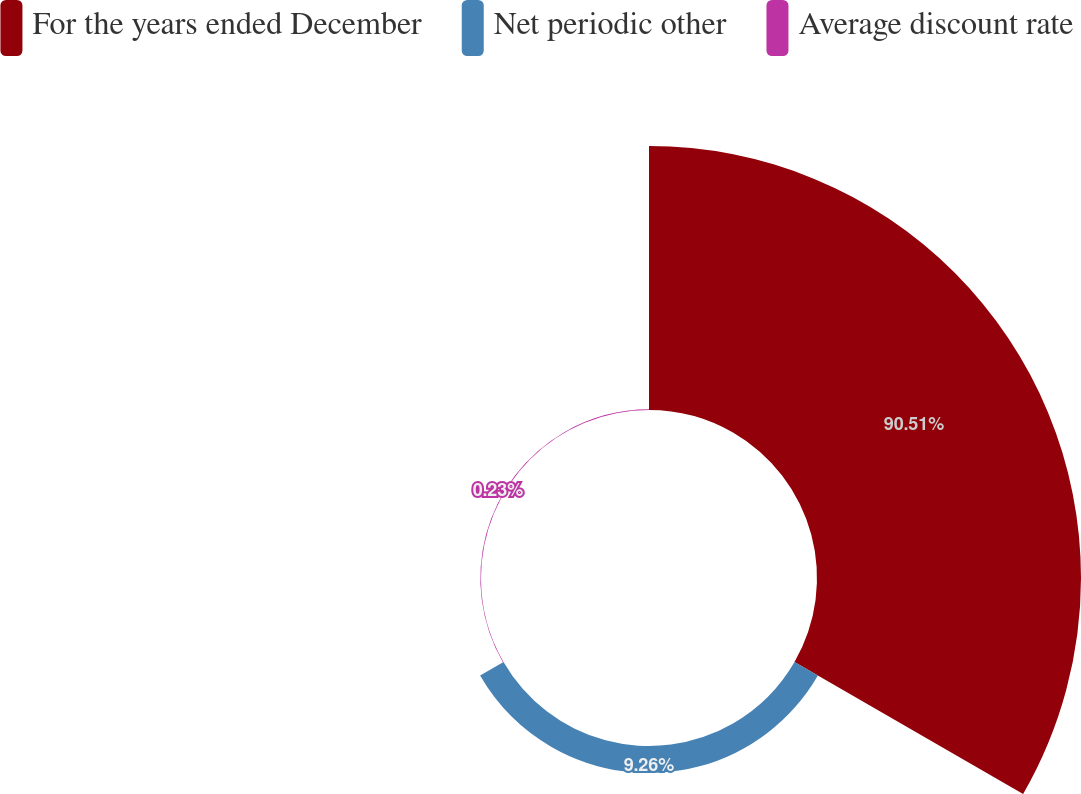<chart> <loc_0><loc_0><loc_500><loc_500><pie_chart><fcel>For the years ended December<fcel>Net periodic other<fcel>Average discount rate<nl><fcel>90.5%<fcel>9.26%<fcel>0.23%<nl></chart> 